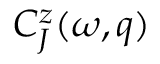Convert formula to latex. <formula><loc_0><loc_0><loc_500><loc_500>C _ { J } ^ { z } ( \omega , q )</formula> 